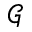Convert formula to latex. <formula><loc_0><loc_0><loc_500><loc_500>\mathcal { G }</formula> 